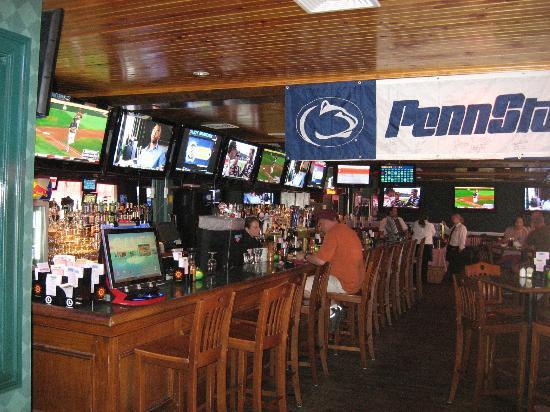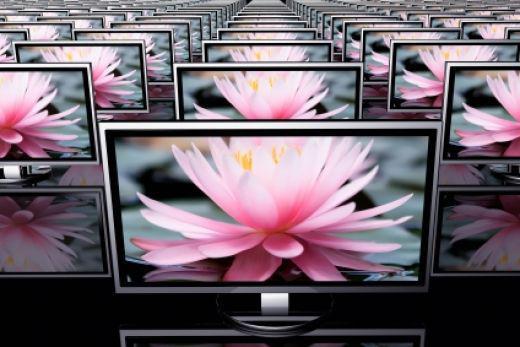The first image is the image on the left, the second image is the image on the right. Considering the images on both sides, is "People are hanging around in a barlike atmosphere in one of the images." valid? Answer yes or no. Yes. The first image is the image on the left, the second image is the image on the right. Evaluate the accuracy of this statement regarding the images: "Left image shows people in a bar with a row of screens overhead.". Is it true? Answer yes or no. Yes. 